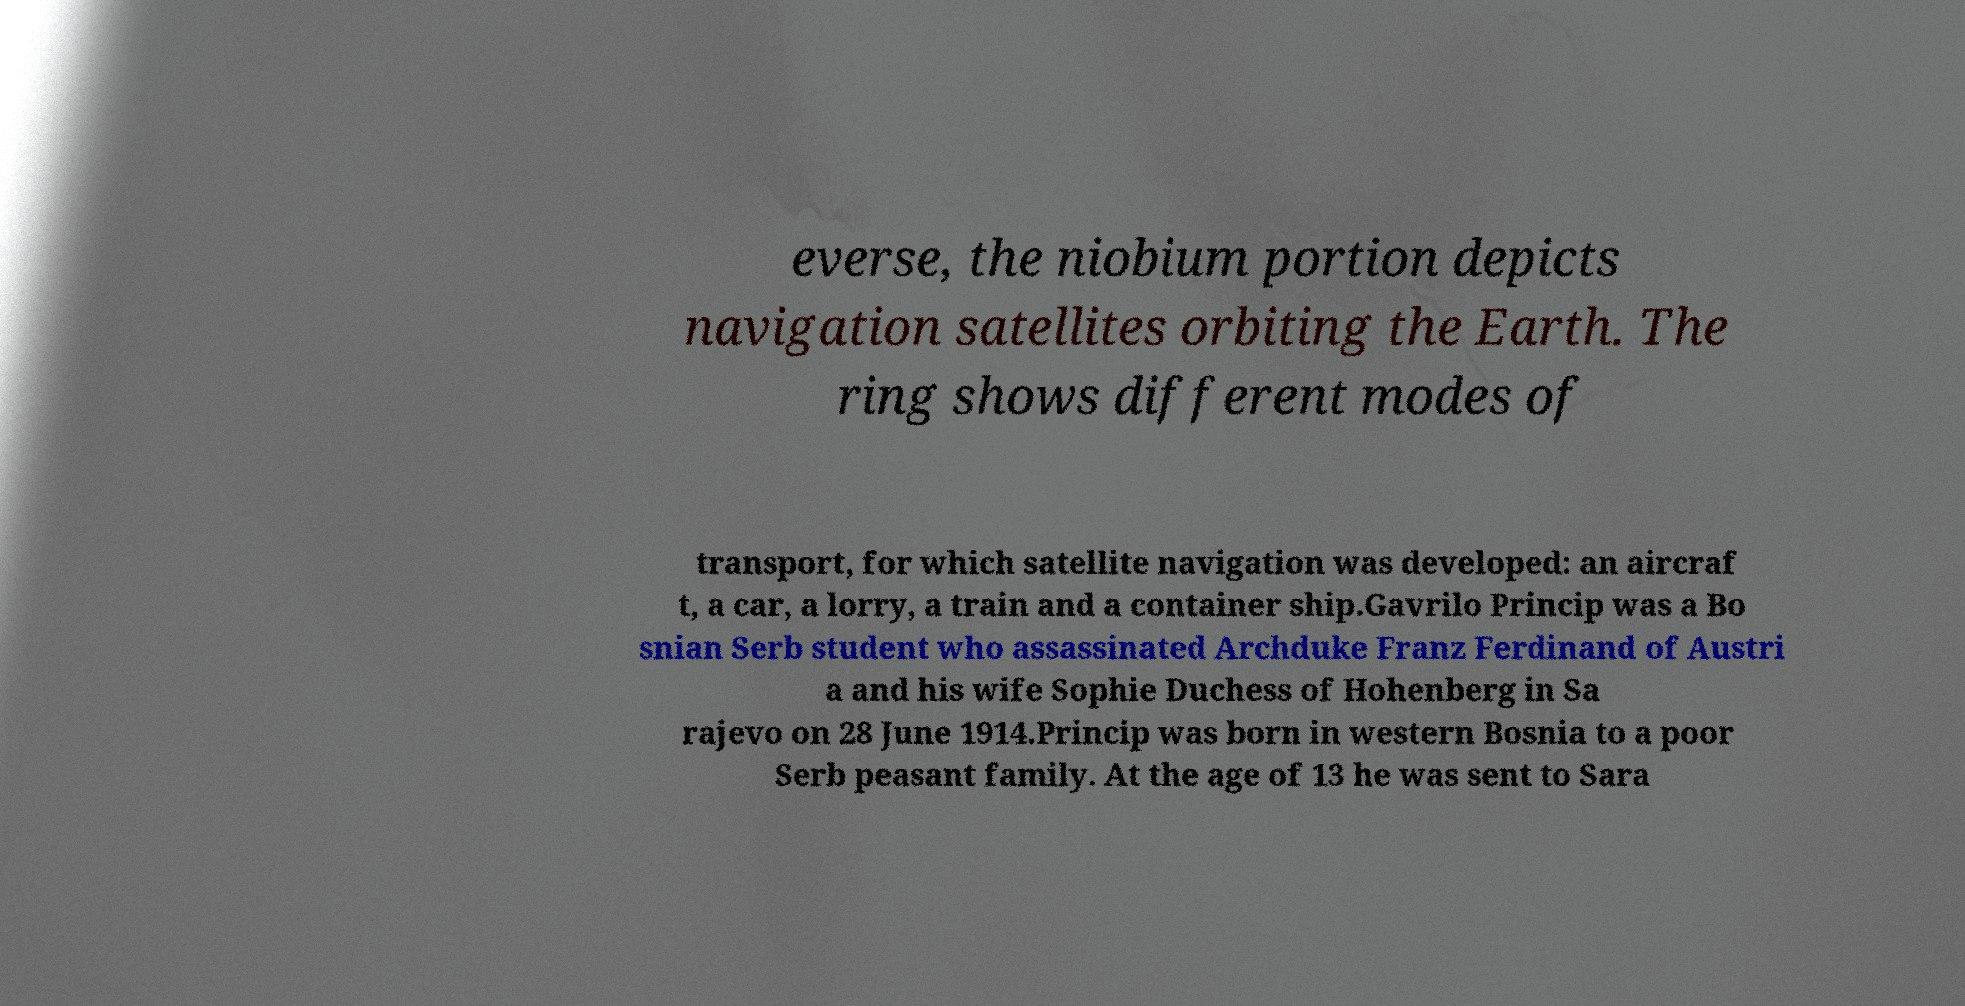I need the written content from this picture converted into text. Can you do that? everse, the niobium portion depicts navigation satellites orbiting the Earth. The ring shows different modes of transport, for which satellite navigation was developed: an aircraf t, a car, a lorry, a train and a container ship.Gavrilo Princip was a Bo snian Serb student who assassinated Archduke Franz Ferdinand of Austri a and his wife Sophie Duchess of Hohenberg in Sa rajevo on 28 June 1914.Princip was born in western Bosnia to a poor Serb peasant family. At the age of 13 he was sent to Sara 